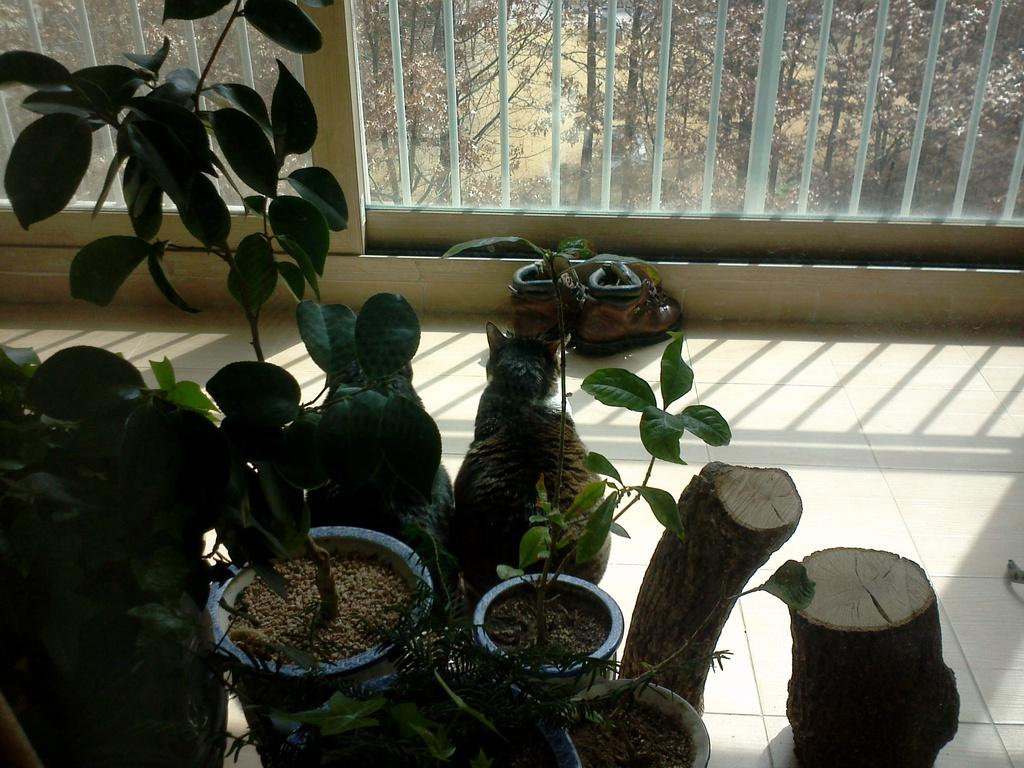What type of plants can be seen in the image? There are house plants in the image. What is located near the house plants? There is a path near the house plants. What architectural feature is present in the image? There is a wall with a glass window in the image. What can be seen through the glass window? Plants and grass are visible through the glass window. What type of science experiment is being conducted by the dad in the image? There is no dad or science experiment present in the image. 